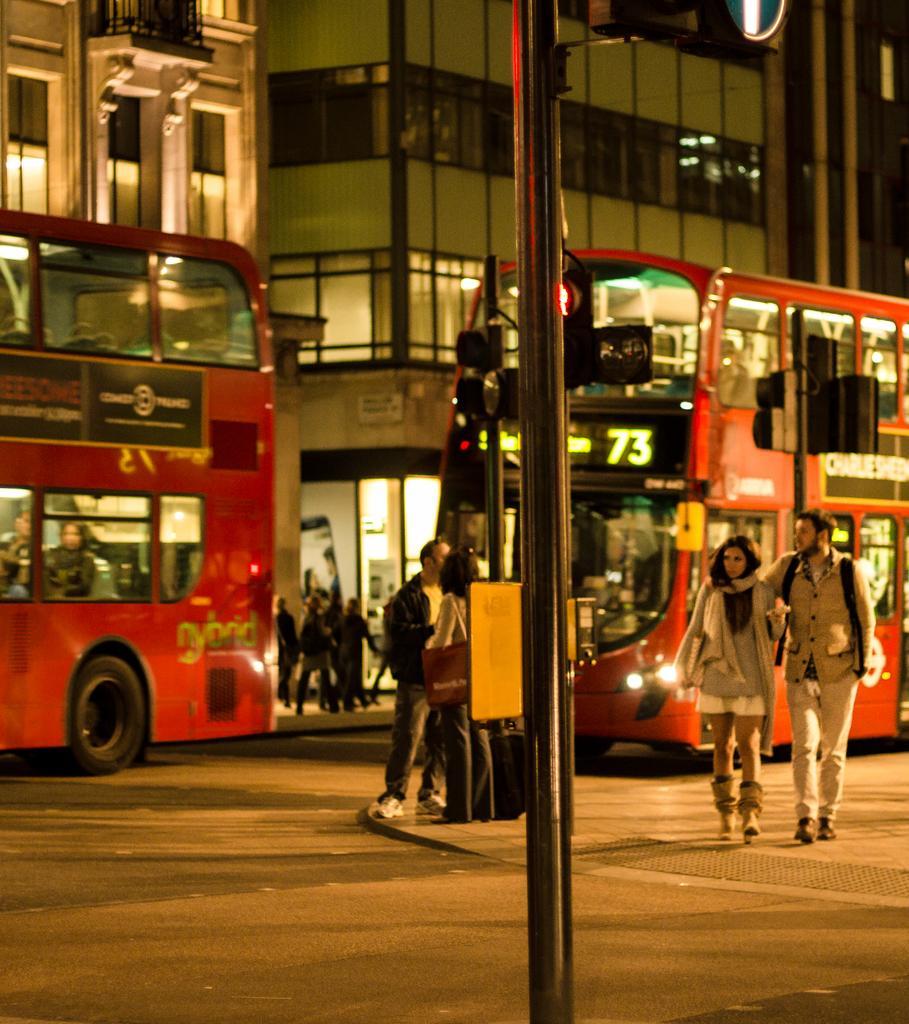In one or two sentences, can you explain what this image depicts? On the road there are buses. Here we can see people. This is black pole. Background there are buildings with glass windows.  